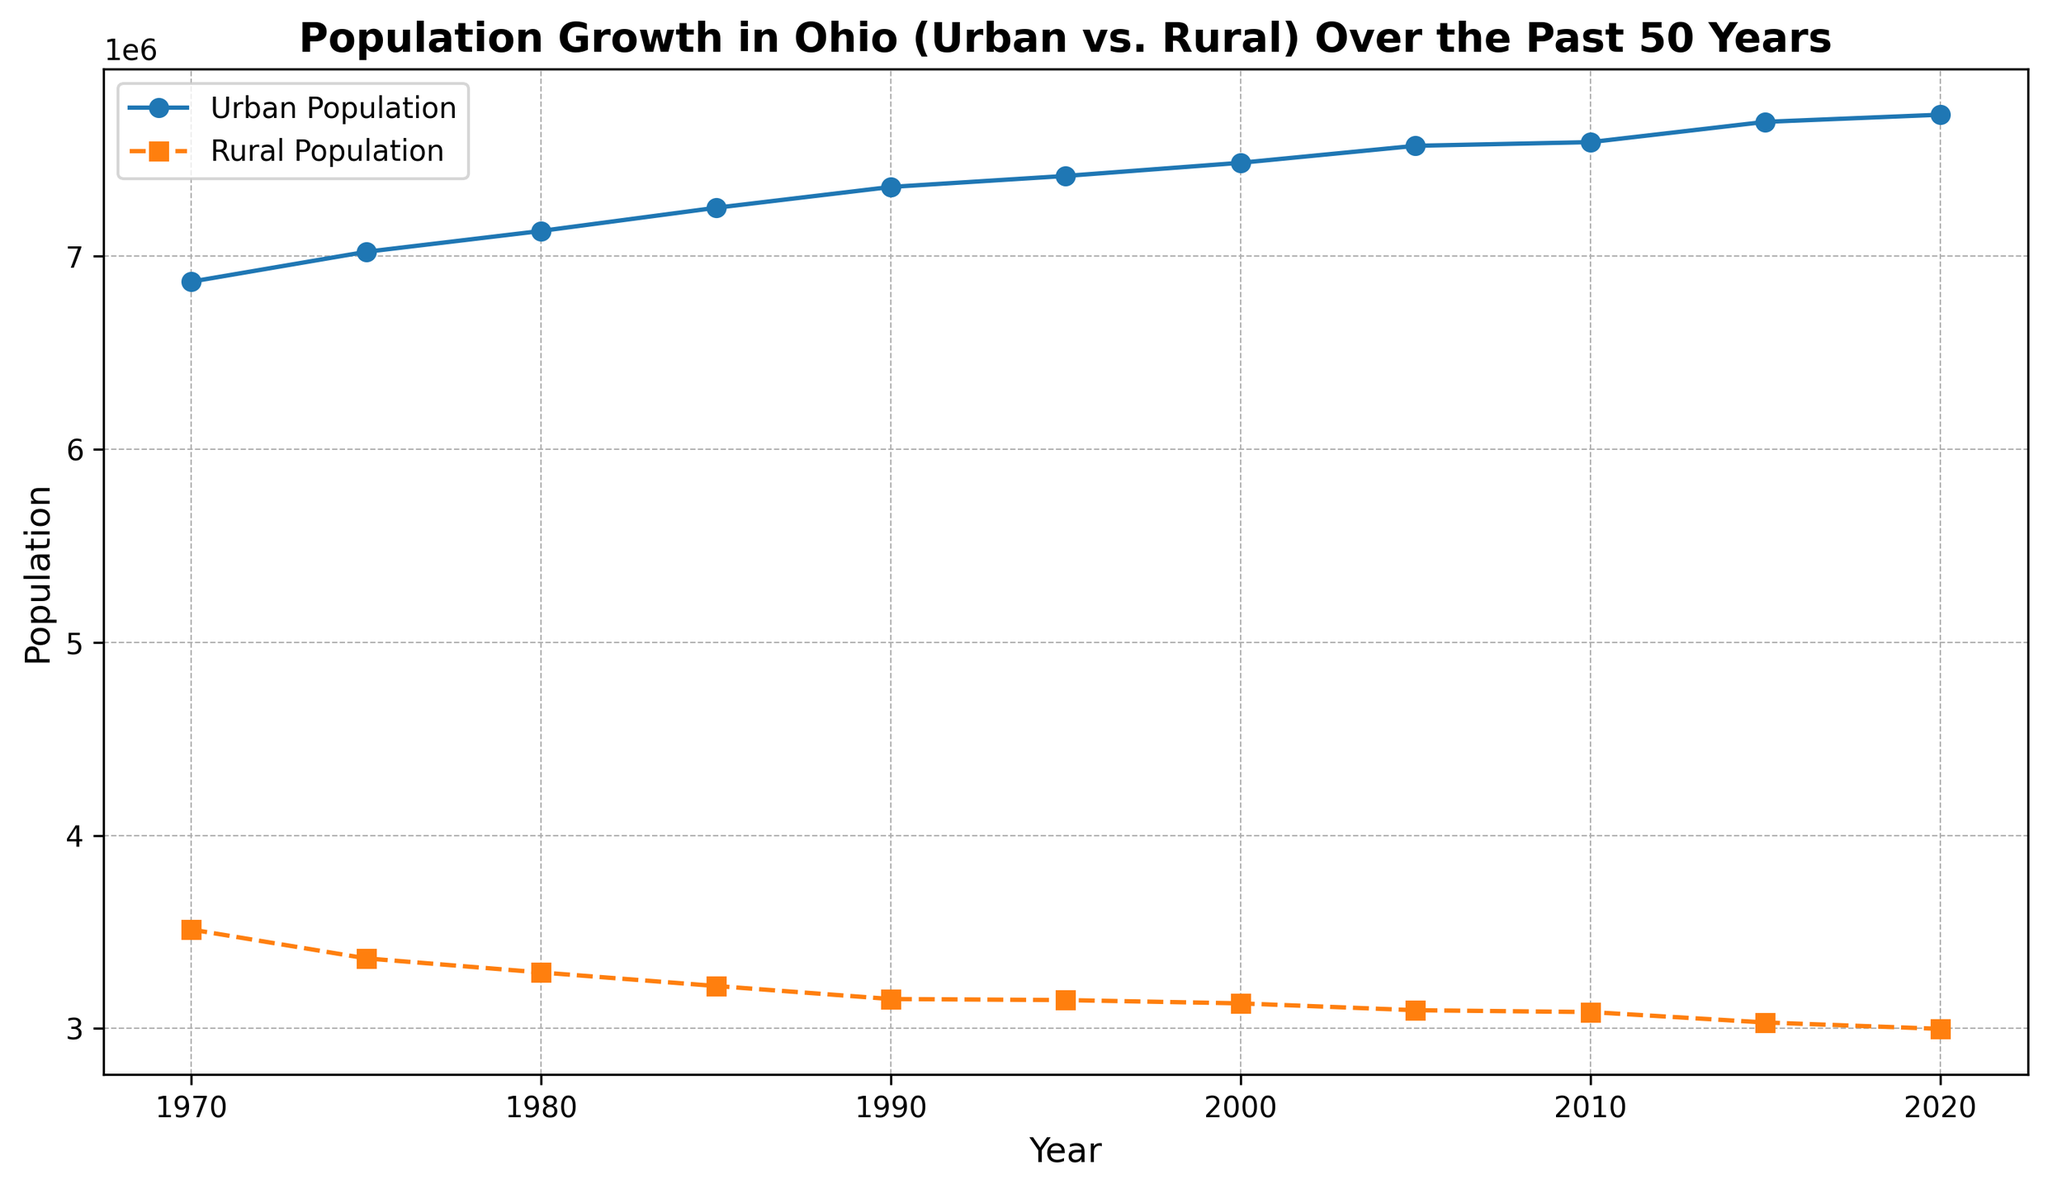What is the difference in Urban Population between 1970 and 2020? In 1970, the Urban Population is 6,867,500, and in 2020 it is 7,732,000. The difference is 7,732,000 - 6,867,500 = 864,500.
Answer: 864,500 Which year has the highest Rural Population? By looking at the plotted data, the Rural Population is highest in 1970 at 3,512,500.
Answer: 1970 What is the average Urban Population over the entire time period? To find the average Urban Population, sum all the Urban Population values and divide by the number of years. The total sum is 86,713,500 over 11 years, so 86,713,500 / 11 = 7,883,045.
Answer: 7,883,045 In what year do the Urban and Rural Population differences peak? The difference between Urban and Rural Population is calculated for each year. The year 2020 shows the largest difference, 7,732,000 - 2,998,000 = 4,734,000.
Answer: 2020 Which population saw a steady increase over the 50 years, urban or rural? Observing the trend lines, the Urban Population steadily increased over the 50 years, while the Rural Population steadily decreased.
Answer: Urban Which year shows the smallest difference between Urban and Rural Population? Calculate the difference each year and find the smallest one. In 1970 the difference is: 6,867,500 - 3,512,500 = 3,355,000, which is the smallest in the dataset.
Answer: 1970 How did the Urban Population change between 1990 and 2000? Urban Population in 1990 is 7,358,000; in 2000 it is 7,483,000. The change is 7,483,000 - 7,358,000 = 125,000.
Answer: 125,000 Compare the visual trends for Urban and Rural Populations. The Urban Population line rises steadily with small increments, while the Rural Population line declines gradually.
Answer: Urban rises, Rural declines Which year shows the first decline in the Rural Population numbers? By observing the plotted points on the chart, the first decline in Rural Population occurs from 1970 to 1975 (from 3,512,500 to 3,363,000).
Answer: 1975 What is the total combined population (Urban and Rural) in 1995? Sum the Urban and Rural Population for 1995: 7,415,000 (Urban) + 3,147,000 (Rural) = 10,562,000.
Answer: 10,562,000 